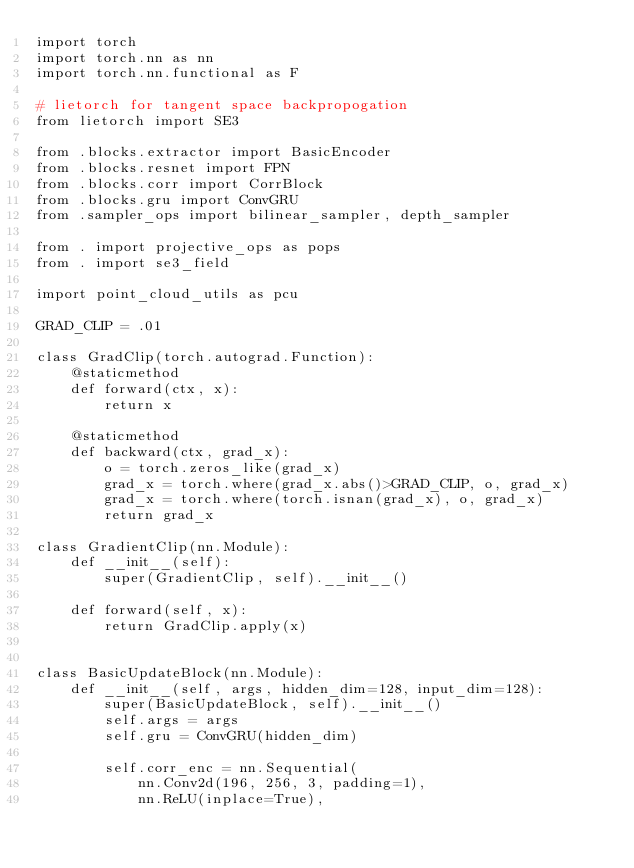<code> <loc_0><loc_0><loc_500><loc_500><_Python_>import torch
import torch.nn as nn
import torch.nn.functional as F

# lietorch for tangent space backpropogation
from lietorch import SE3

from .blocks.extractor import BasicEncoder
from .blocks.resnet import FPN
from .blocks.corr import CorrBlock
from .blocks.gru import ConvGRU
from .sampler_ops import bilinear_sampler, depth_sampler

from . import projective_ops as pops
from . import se3_field

import point_cloud_utils as pcu

GRAD_CLIP = .01

class GradClip(torch.autograd.Function):
    @staticmethod
    def forward(ctx, x):
        return x

    @staticmethod
    def backward(ctx, grad_x):
        o = torch.zeros_like(grad_x)
        grad_x = torch.where(grad_x.abs()>GRAD_CLIP, o, grad_x)
        grad_x = torch.where(torch.isnan(grad_x), o, grad_x)
        return grad_x

class GradientClip(nn.Module):
    def __init__(self):
        super(GradientClip, self).__init__()

    def forward(self, x):
        return GradClip.apply(x)


class BasicUpdateBlock(nn.Module):
    def __init__(self, args, hidden_dim=128, input_dim=128):
        super(BasicUpdateBlock, self).__init__()
        self.args = args
        self.gru = ConvGRU(hidden_dim)

        self.corr_enc = nn.Sequential(
            nn.Conv2d(196, 256, 3, padding=1),
            nn.ReLU(inplace=True),</code> 